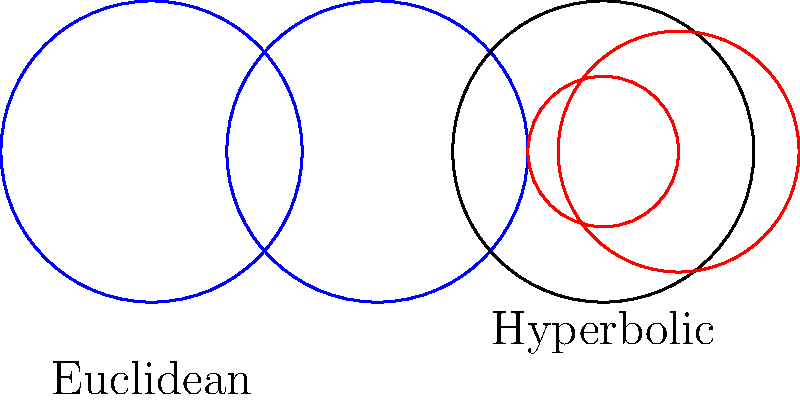In the context of your business's legal strategy, consider the visualization of circles in Euclidean and hyperbolic geometries. How does the behavior of circles in the hyperbolic plane (right) differ from those in the Euclidean plane (left), and how might this analogy relate to adapting your defense approach in the wrongful termination lawsuit? To understand the difference between circles in Euclidean and hyperbolic geometries and relate it to the legal strategy:

1. Euclidean plane (left):
   - Circles maintain their shape regardless of position
   - They have constant curvature
   - Parallel lines never intersect

2. Hyperbolic plane (right):
   - Circles appear distorted, especially near the boundary
   - Their curvature increases as they approach the edge
   - Parallel lines can diverge

3. Relation to legal strategy:
   - Euclidean circles represent a rigid, one-size-fits-all approach
   - Hyperbolic circles symbolize the need for flexibility and adaptation
   - As the case moves towards critical areas (edge of the disk), strategies may need significant adjustment

4. Application to wrongful termination defense:
   - Recognize that standard defenses may not work uniformly (like distorted circles)
   - Be prepared to adjust arguments as new evidence emerges (adapting to increasing curvature)
   - Consider multiple parallel strategies that may diverge (like parallel lines in hyperbolic space)

5. Key takeaway:
   - Just as circles behave differently in hyperbolic space, legal strategies must adapt to the unique aspects of the case, especially as it progresses towards critical points.
Answer: Adaptive strategy: Flexible approach adjusting to case complexity, like circles distorting in hyperbolic space. 